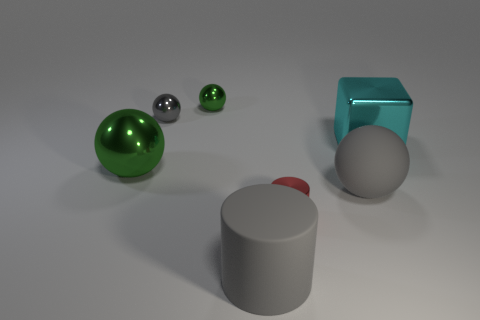Add 1 red metallic blocks. How many objects exist? 8 Subtract all cubes. How many objects are left? 6 Add 6 blocks. How many blocks are left? 7 Add 5 large gray cylinders. How many large gray cylinders exist? 6 Subtract 0 yellow cubes. How many objects are left? 7 Subtract all big gray things. Subtract all gray rubber cylinders. How many objects are left? 4 